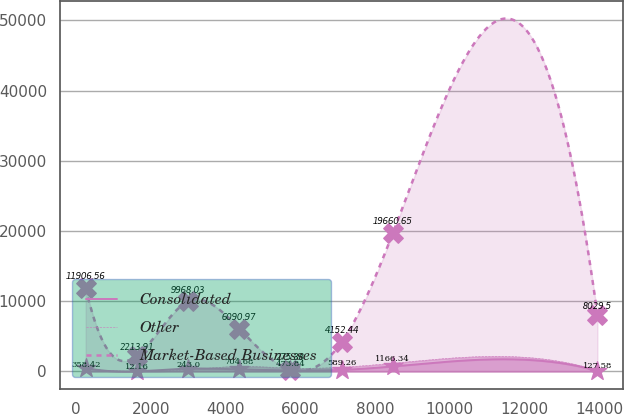Convert chart. <chart><loc_0><loc_0><loc_500><loc_500><line_chart><ecel><fcel>Consolidated<fcel>Other<fcel>Market-Based Businesses<nl><fcel>256.18<fcel>512.15<fcel>358.42<fcel>11906.6<nl><fcel>1625.64<fcel>13.46<fcel>12.16<fcel>2213.91<nl><fcel>2995.1<fcel>397.06<fcel>243<fcel>9968.03<nl><fcel>4364.56<fcel>292.26<fcel>704.68<fcel>6090.97<nl><fcel>5734.02<fcel>152.86<fcel>473.84<fcel>275.38<nl><fcel>7103.48<fcel>222.56<fcel>589.26<fcel>4152.44<nl><fcel>8472.94<fcel>710.45<fcel>1166.34<fcel>19660.7<nl><fcel>13950.8<fcel>83.16<fcel>127.58<fcel>8029.5<nl></chart> 